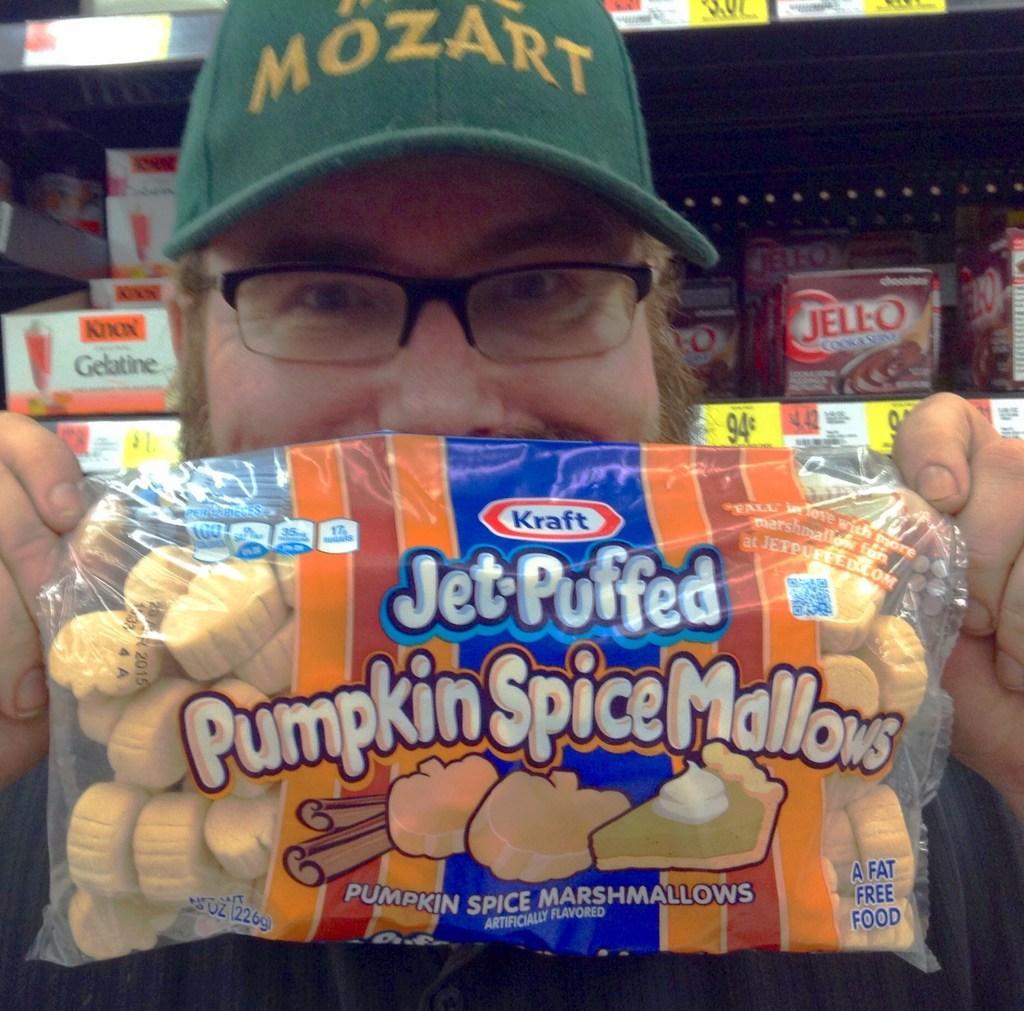Describe this image in one or two sentences. In this image, we can see a man holding a packet, he is wearing a hat and specs, in the background, we can see some products in the rack. 